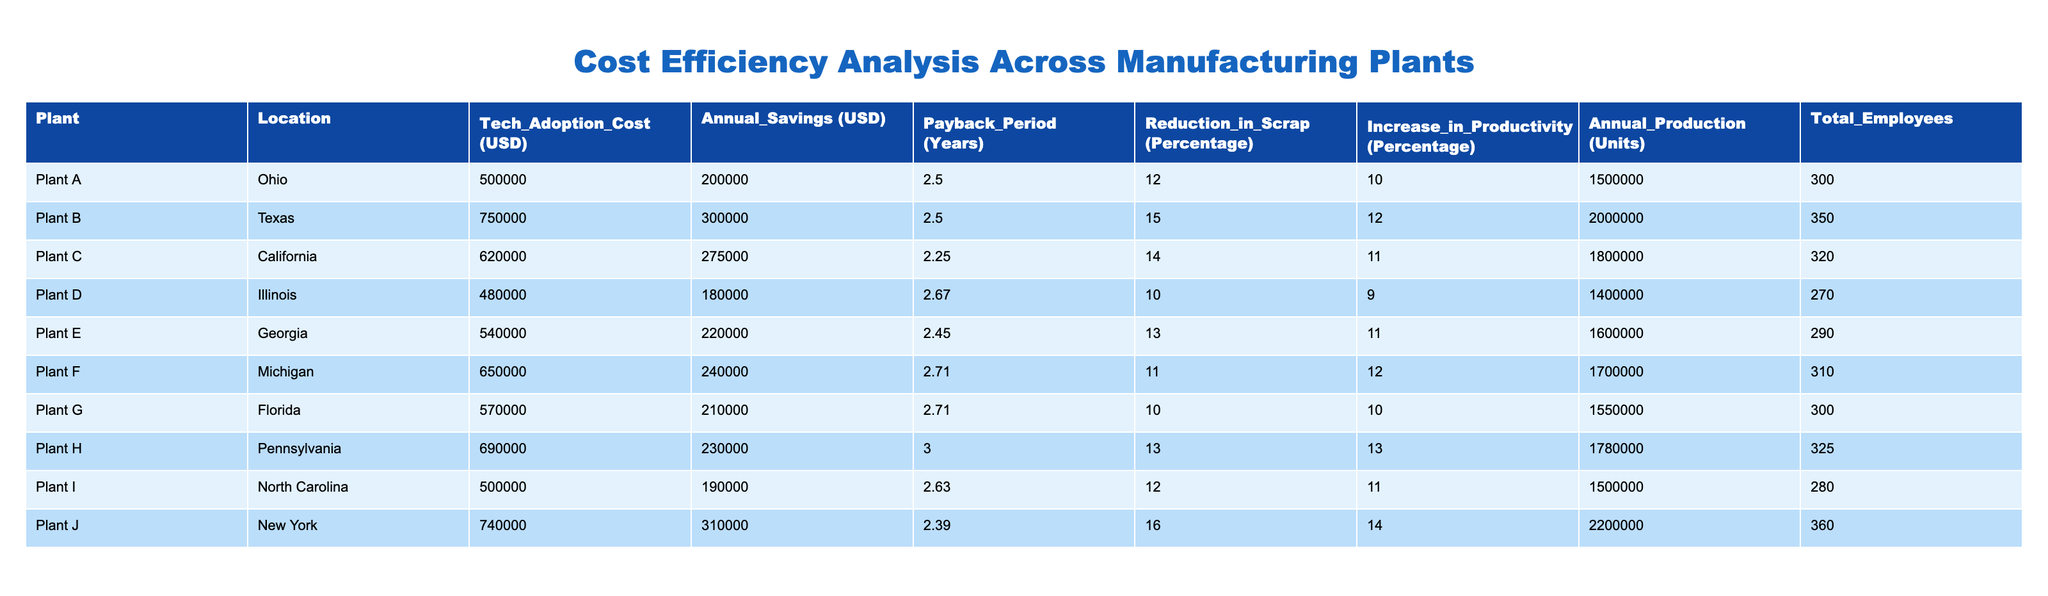What is the Technology Adoption Cost for Plant B? The table lists the Technology Adoption Cost for each plant. For Plant B, the cost is explicitly stated in the corresponding row, which is 750000 USD.
Answer: 750000 USD Which plant has the longest Payback Period? The Payback Period values for the plants are compared by looking at the corresponding column. Plant H has the highest Payback Period at 3.0 years.
Answer: Plant H What is the average Annual Savings across all plants? To calculate the average Annual Savings, sum the Annual Savings values from all plants (200000 + 300000 + 275000 + 180000 + 220000 + 240000 + 210000 + 230000 + 190000 + 310000 =  2180000 USD) and then divide by the number of plants (10). Therefore, 2180000 / 10 = 218000 USD.
Answer: 218000 USD Is Plant E more cost-effective than Plant F based on Annual Savings? First, compare the Annual Savings for both plants. Plant E has Annual Savings of 220000 USD, and Plant F has 240000 USD. Since 240000 > 220000, Plant E is not more cost-effective than Plant F.
Answer: No What percentage reduction in scrap does Plant J achieve compared to Plant D? First, locate the Reduction in Scrap percentage for both plants. Plant J has 16% and Plant D has 10%. The difference is calculated as: 16% - 10% = 6%. Therefore, Plant J achieves a 6% higher reduction in scrap compared to Plant D.
Answer: 6% Which plant has the highest Annual Production? Comparing the Annual Production column, Plant J has the highest value at 2200000 units.
Answer: Plant J How many more employees does Plant B have compared to Plant D? Calculate the difference in the Total Employees between Plant B (350) and Plant D (270). The calculation would be: 350 - 270 = 80. Thus, Plant B has 80 more employees than Plant D.
Answer: 80 Which two plants together achieve a total Annual Saving greater than 600000 USD? By reviewing the Annual Savings for each plant, you can see that combinations such as Plant B (300000) and Plant J (310000) total 610000 USD, which is greater than 600000 USD. Testing other combinations can confirm this.
Answer: Plant B and Plant J 